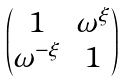<formula> <loc_0><loc_0><loc_500><loc_500>\begin{pmatrix} 1 & \omega ^ { \xi } \\ \omega ^ { - \xi } & 1 \end{pmatrix}</formula> 